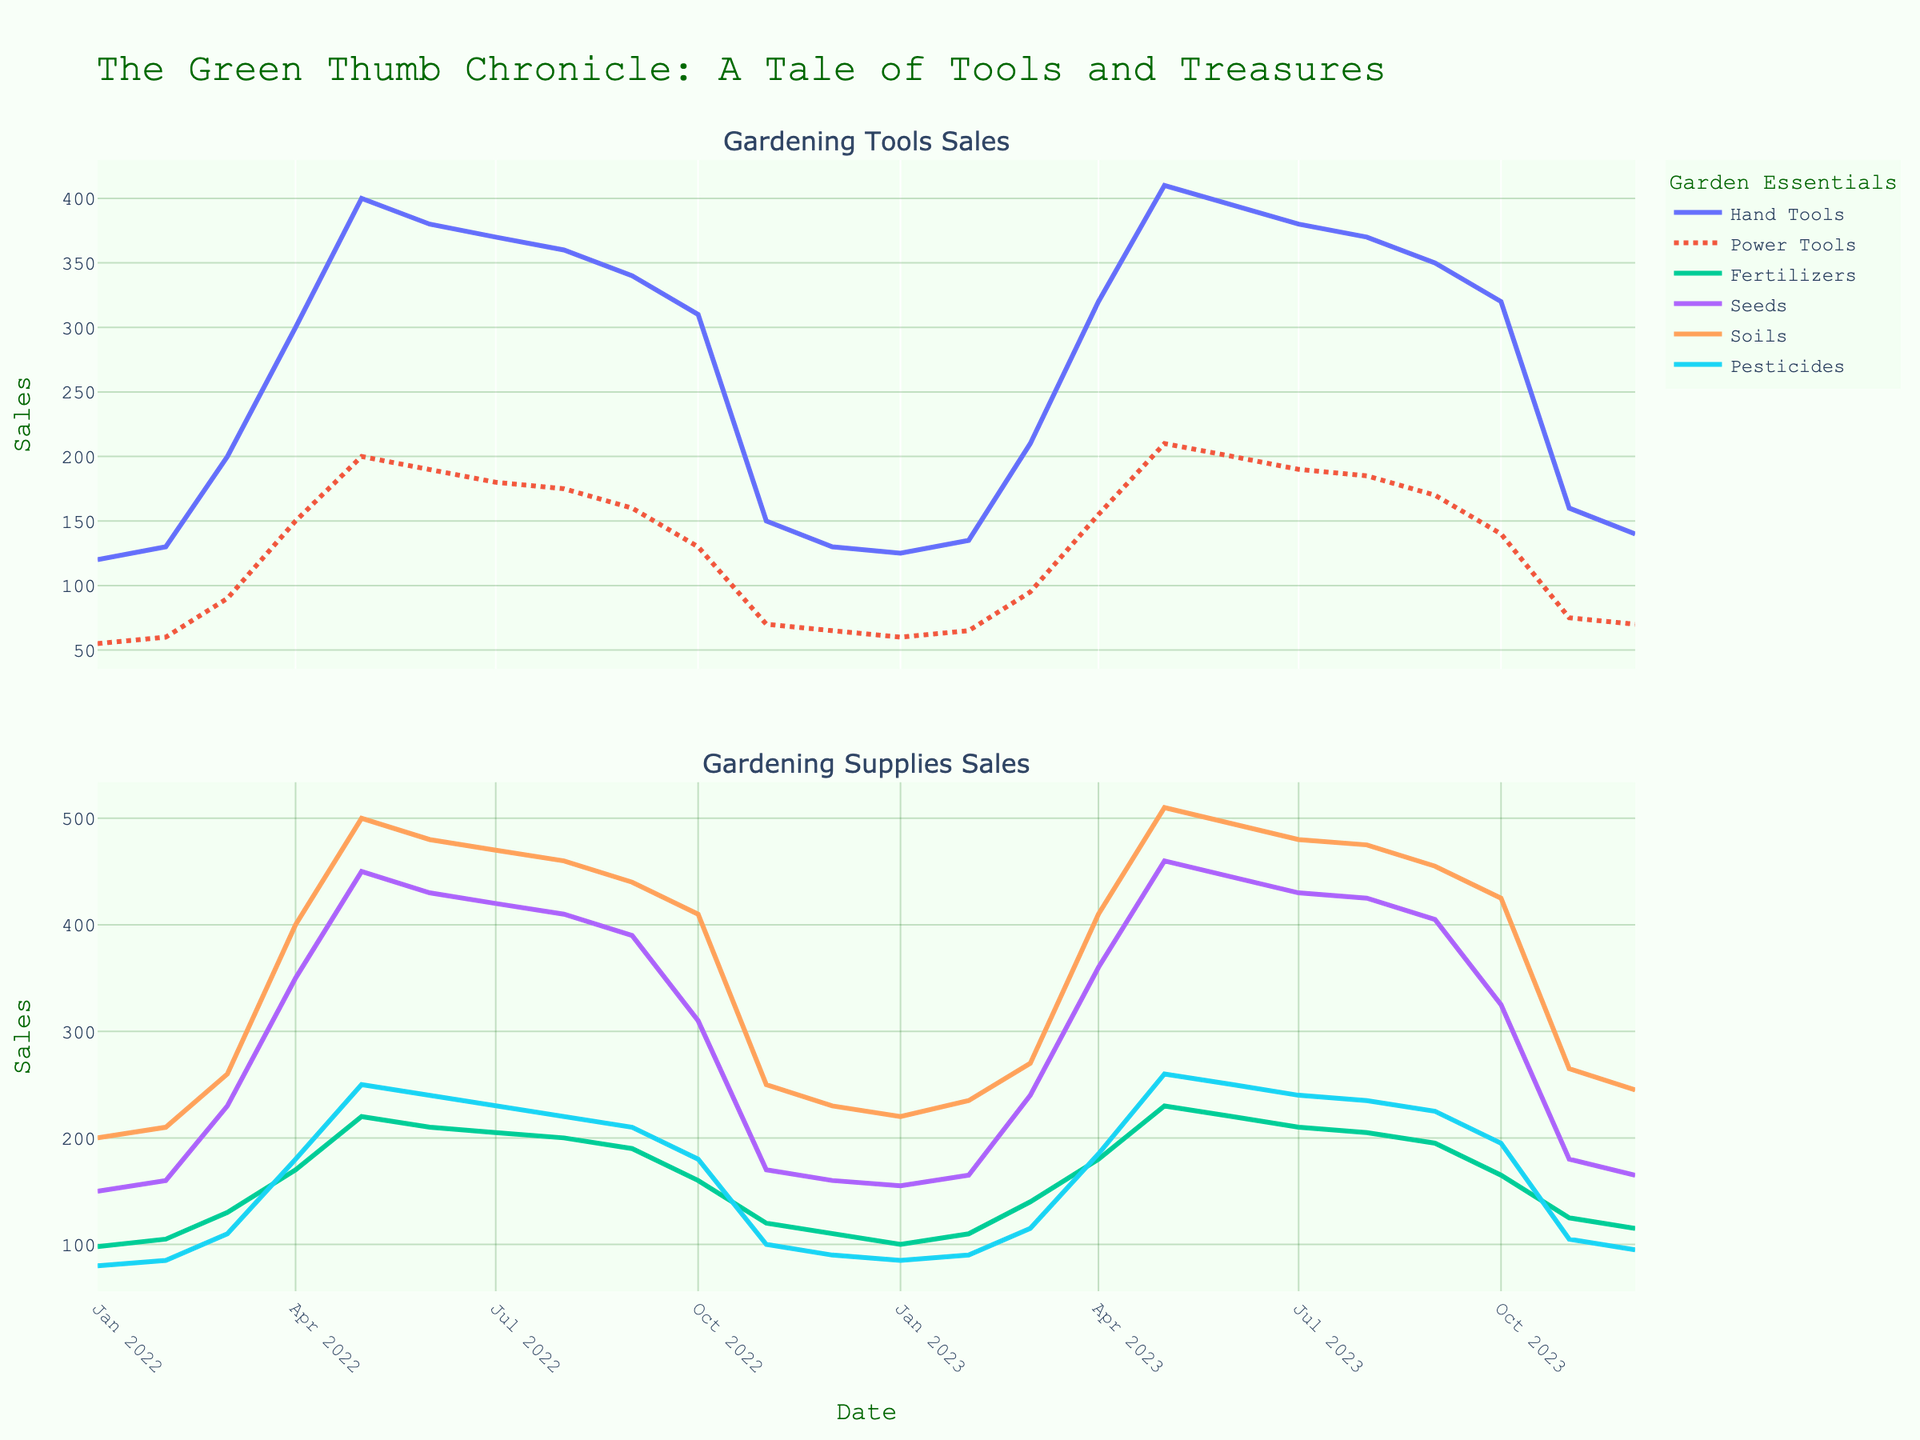Which month in the dataset shows the highest sales for Hand Tools? The figure shows the monthly sales of Hand Tools over time. To find the month with the highest sales, observe the peak on the line for Hand Tools. The peak is in May.
Answer: May What general trend do you notice for Pesticides sales over the given time period? Observe the line corresponding to Pesticides. Initially, there is an increase from January to May, a slight decrease in the middle months, and then a notable drop starting from October onwards. Overall, the trend is seasonal with peaks in spring and minimal sales in late fall and winter.
Answer: Seasonal with spring peaks How do sales of Power Tools in March 2023 compare to March 2022? Check the figure for the sales values of Power Tools in both March 2022 and March 2023. For March 2022, the sales are around 90 units, and for March 2023, they are around 95 units.
Answer: March 2023 is higher Which gardening supply had the highest sales in April 2022, and how much was it? To find the highest sales in April 2022 among gardening supplies like Fertilizers, Seeds, Soils, and Pesticides, look at the data points for that month. The highest is Soils with 400 units.
Answer: Soils, 400 units Considering the growth trend, what is the percentage increase in Hand Tools sales from January 2022 to May 2022? Hand Tools sales in January 2022 were 120 units and in May 2022 were 400 units. The percentage increase is calculated as ((400 - 120) / 120) * 100% = 233.33%.
Answer: 233.33% During which months did Seeds sales exceed 400 units? Look at the line for Seeds and identify the months where the values exceed 400 units. These months are April, May, and June of both years.
Answer: April, May, June Do any gardening tools or supplies show a consistent sales increase or decrease over the entire timeframe? Observe each line plot for any consistent upward or downward trends. Seeds show a seasonal pattern without consistent increase or decrease, while others like Hand Tools and Soils exhibit similar seasonal fluctuations.
Answer: No consistent trend What is the average sales of Soils during the peak months of May for both years combined? The sales of Soils in May 2022 are 500 units and in May 2023 are 510 units. To find the average: (500 + 510) / 2 = 505 units.
Answer: 505 units 